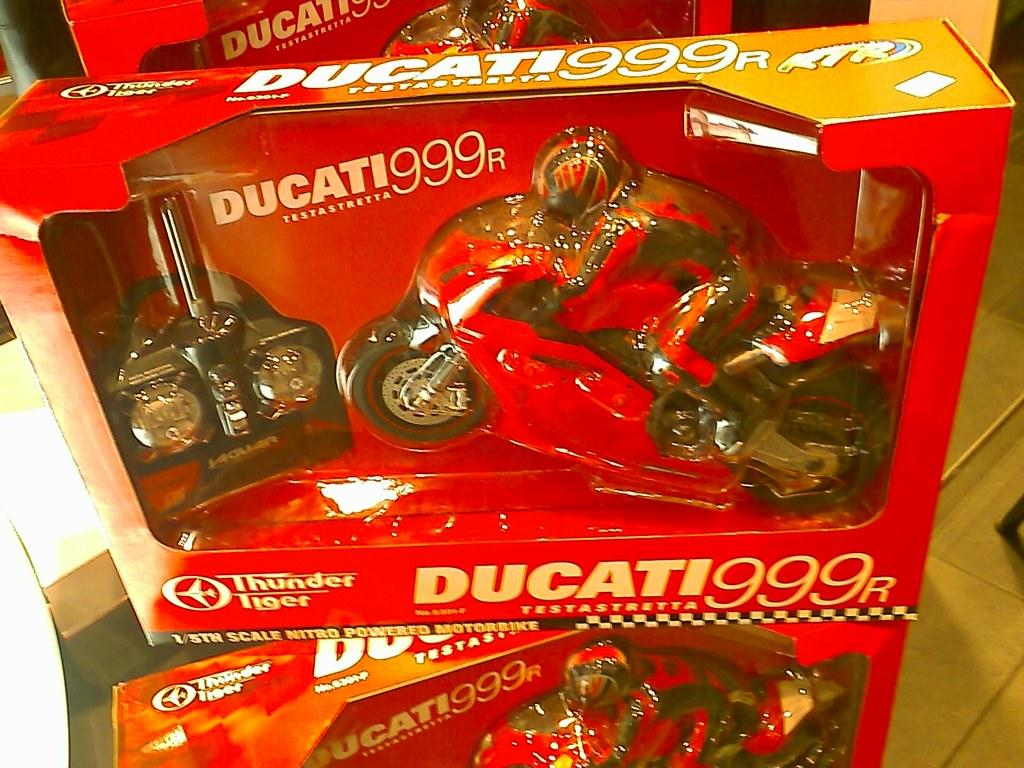What type of containers are visible in the image? There are cotton boxes in the image. What items can be found inside the cotton boxes? Toys and bikes are present in the cotton boxes. Where are the cotton boxes located? The cotton boxes are on a table. What type of flooring is visible on the right side of the image? There is a wooden floor on the right side of the image. How does the hair on the toys react during the rainstorm in the image? There is no rainstorm present in the image, and the toys do not have hair. 